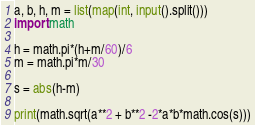<code> <loc_0><loc_0><loc_500><loc_500><_Python_>a, b, h, m = list(map(int, input().split()))
import math
 
h = math.pi*(h+m/60)/6
m = math.pi*m/30
 
s = abs(h-m)
 
print(math.sqrt(a**2 + b**2 -2*a*b*math.cos(s)))</code> 